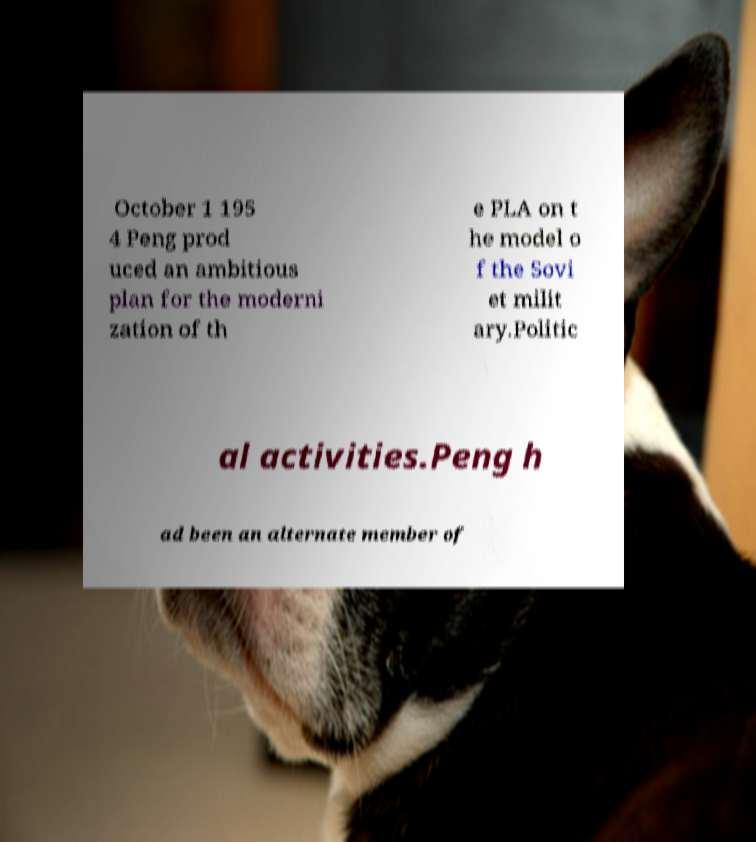I need the written content from this picture converted into text. Can you do that? October 1 195 4 Peng prod uced an ambitious plan for the moderni zation of th e PLA on t he model o f the Sovi et milit ary.Politic al activities.Peng h ad been an alternate member of 